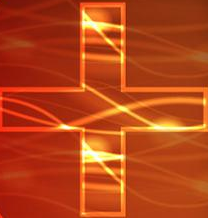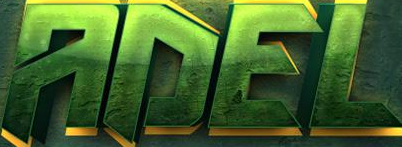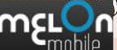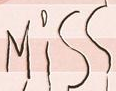Read the text from these images in sequence, separated by a semicolon. +; ADEL; mɛLon; Miss 